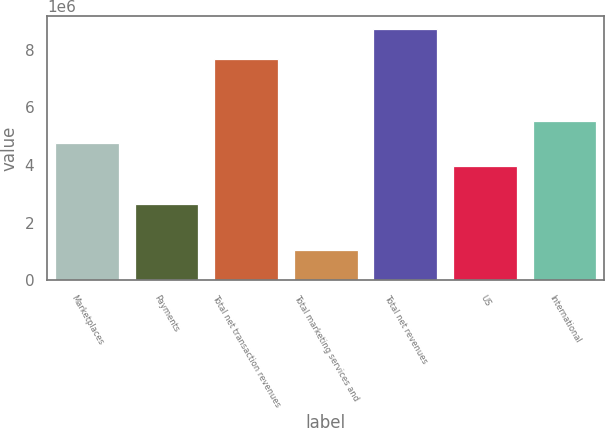Convert chart. <chart><loc_0><loc_0><loc_500><loc_500><bar_chart><fcel>Marketplaces<fcel>Payments<fcel>Total net transaction revenues<fcel>Total marketing services and<fcel>Total net revenues<fcel>US<fcel>International<nl><fcel>4.75288e+06<fcel>2.64119e+06<fcel>7.67814e+06<fcel>1.04923e+06<fcel>8.72736e+06<fcel>3.98507e+06<fcel>5.5207e+06<nl></chart> 